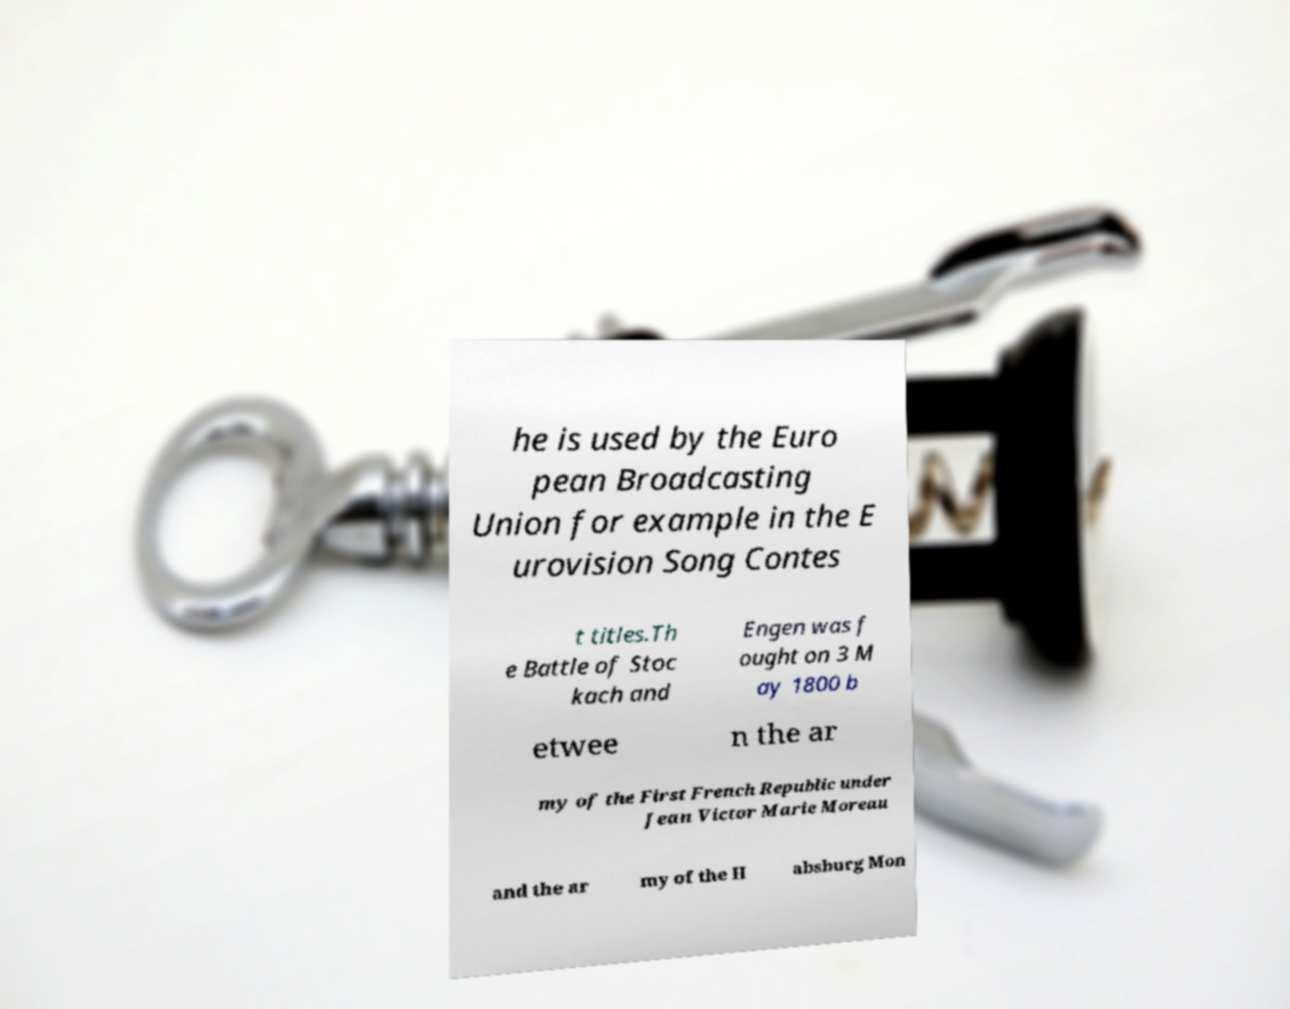Can you read and provide the text displayed in the image?This photo seems to have some interesting text. Can you extract and type it out for me? he is used by the Euro pean Broadcasting Union for example in the E urovision Song Contes t titles.Th e Battle of Stoc kach and Engen was f ought on 3 M ay 1800 b etwee n the ar my of the First French Republic under Jean Victor Marie Moreau and the ar my of the H absburg Mon 